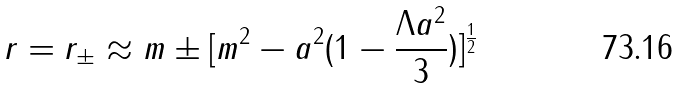Convert formula to latex. <formula><loc_0><loc_0><loc_500><loc_500>r = r _ { \pm } \approx m \pm [ m ^ { 2 } - a ^ { 2 } ( 1 - \frac { \Lambda a ^ { 2 } } { 3 } ) ] ^ { \frac { 1 } { 2 } }</formula> 